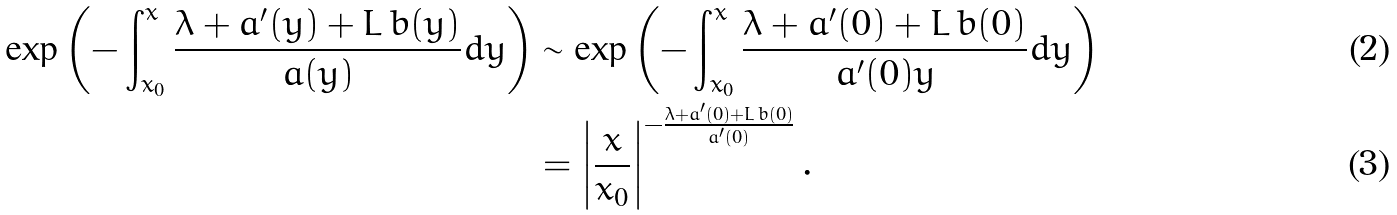<formula> <loc_0><loc_0><loc_500><loc_500>\exp \left ( - \int _ { x _ { 0 } } ^ { x } \frac { \lambda + a ^ { \prime } ( y ) + L \, b ( y ) } { a ( y ) } d y \right ) & \sim \exp \left ( - \int _ { x _ { 0 } } ^ { x } \frac { \lambda + a ^ { \prime } ( 0 ) + L \, b ( 0 ) } { a ^ { \prime } ( 0 ) y } d y \right ) \\ & = \left | \frac { x } { x _ { 0 } } \right | ^ { - \frac { \lambda + a ^ { \prime } ( 0 ) + L \, b ( 0 ) } { a ^ { \prime } ( 0 ) } } .</formula> 